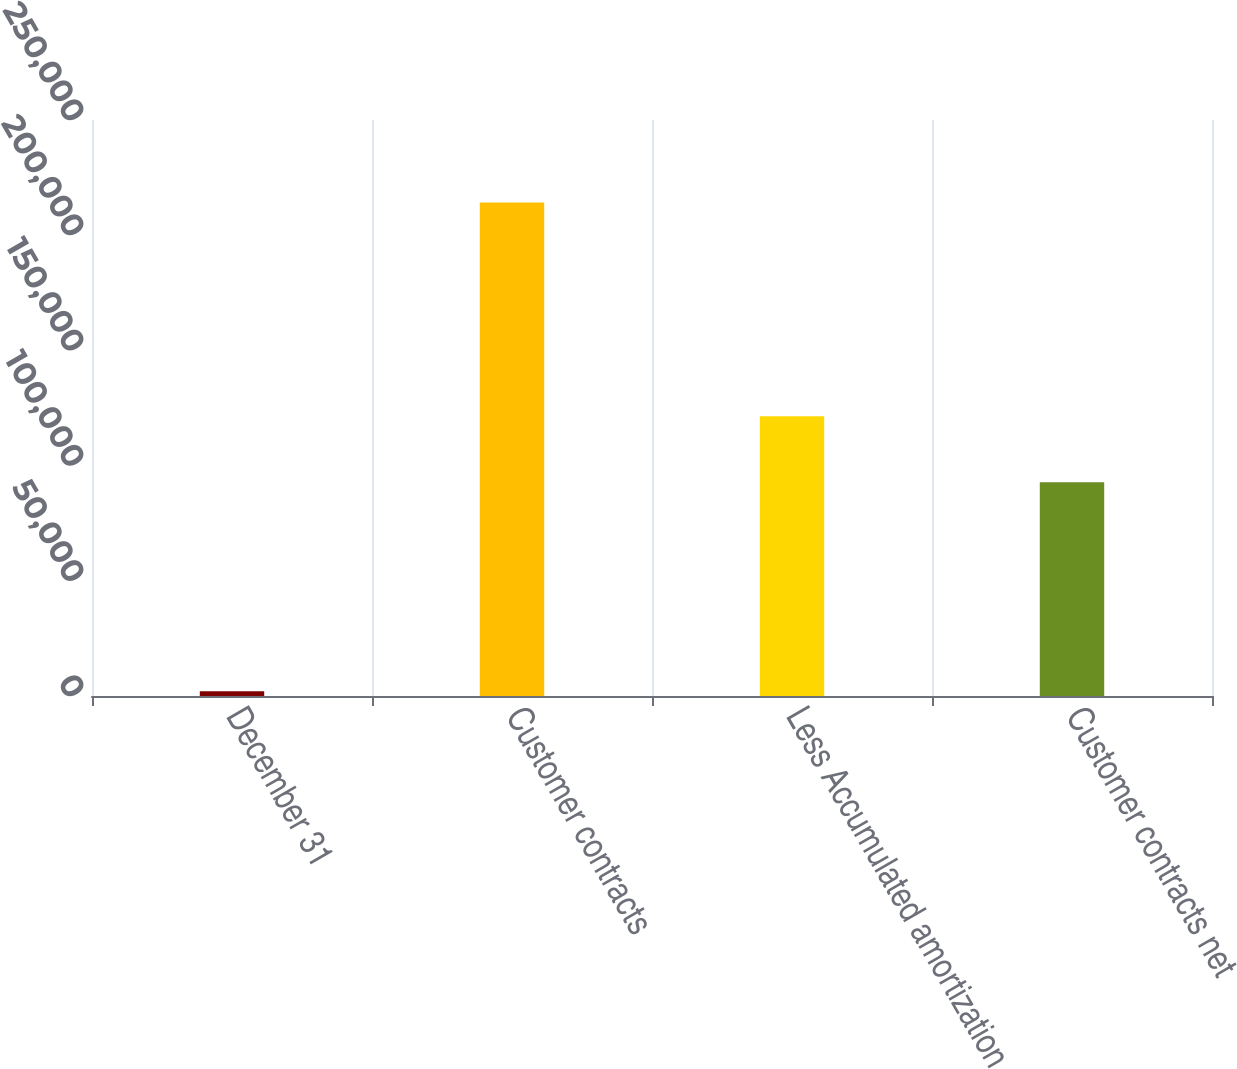Convert chart. <chart><loc_0><loc_0><loc_500><loc_500><bar_chart><fcel>December 31<fcel>Customer contracts<fcel>Less Accumulated amortization<fcel>Customer contracts net<nl><fcel>2015<fcel>214201<fcel>121386<fcel>92815<nl></chart> 